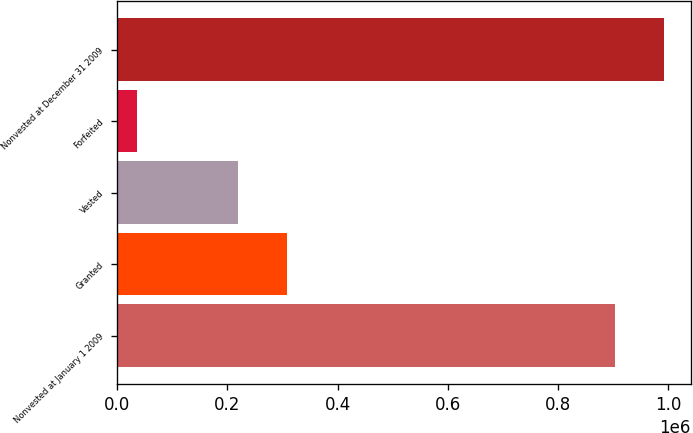<chart> <loc_0><loc_0><loc_500><loc_500><bar_chart><fcel>Nonvested at January 1 2009<fcel>Granted<fcel>Vested<fcel>Forfeited<fcel>Nonvested at December 31 2009<nl><fcel>903200<fcel>307668<fcel>219282<fcel>36738<fcel>991586<nl></chart> 